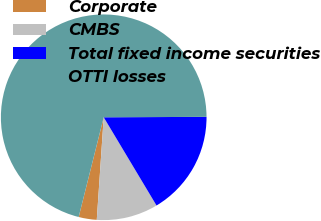Convert chart to OTSL. <chart><loc_0><loc_0><loc_500><loc_500><pie_chart><fcel>Corporate<fcel>CMBS<fcel>Total fixed income securities<fcel>OTTI losses<nl><fcel>2.84%<fcel>9.66%<fcel>16.48%<fcel>71.02%<nl></chart> 